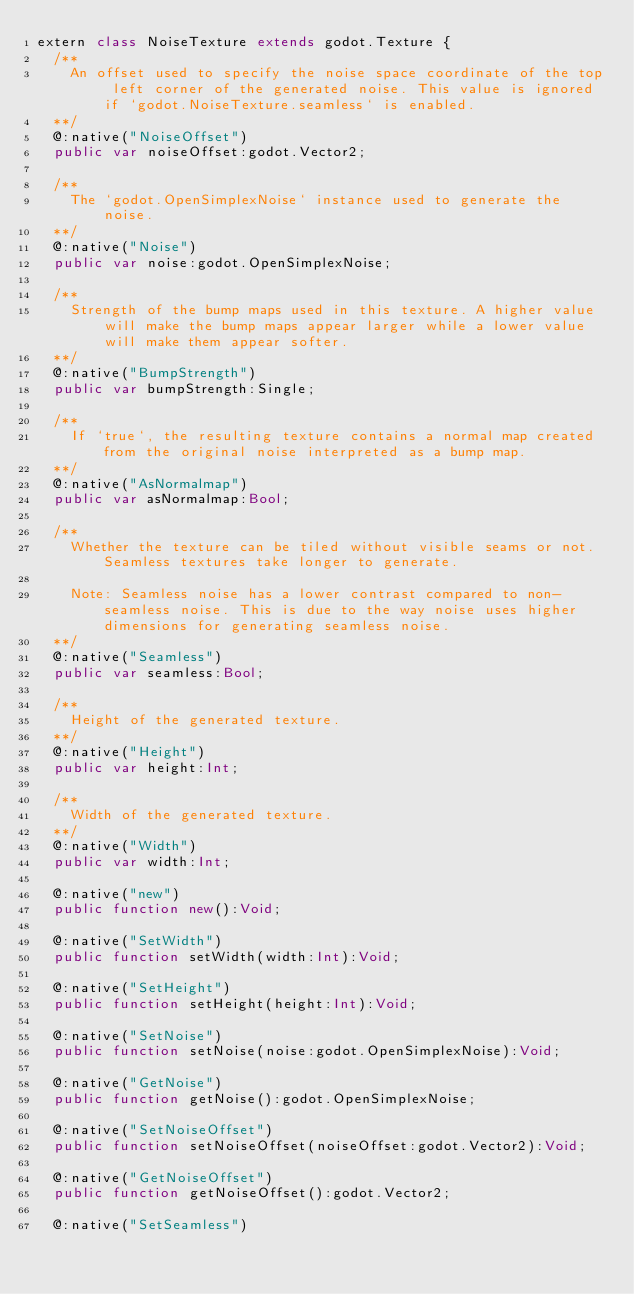<code> <loc_0><loc_0><loc_500><loc_500><_Haxe_>extern class NoiseTexture extends godot.Texture {
	/**		
		An offset used to specify the noise space coordinate of the top left corner of the generated noise. This value is ignored if `godot.NoiseTexture.seamless` is enabled.
	**/
	@:native("NoiseOffset")
	public var noiseOffset:godot.Vector2;

	/**		
		The `godot.OpenSimplexNoise` instance used to generate the noise.
	**/
	@:native("Noise")
	public var noise:godot.OpenSimplexNoise;

	/**		
		Strength of the bump maps used in this texture. A higher value will make the bump maps appear larger while a lower value will make them appear softer.
	**/
	@:native("BumpStrength")
	public var bumpStrength:Single;

	/**		
		If `true`, the resulting texture contains a normal map created from the original noise interpreted as a bump map.
	**/
	@:native("AsNormalmap")
	public var asNormalmap:Bool;

	/**		
		Whether the texture can be tiled without visible seams or not. Seamless textures take longer to generate.
		
		Note: Seamless noise has a lower contrast compared to non-seamless noise. This is due to the way noise uses higher dimensions for generating seamless noise.
	**/
	@:native("Seamless")
	public var seamless:Bool;

	/**		
		Height of the generated texture.
	**/
	@:native("Height")
	public var height:Int;

	/**		
		Width of the generated texture.
	**/
	@:native("Width")
	public var width:Int;

	@:native("new")
	public function new():Void;

	@:native("SetWidth")
	public function setWidth(width:Int):Void;

	@:native("SetHeight")
	public function setHeight(height:Int):Void;

	@:native("SetNoise")
	public function setNoise(noise:godot.OpenSimplexNoise):Void;

	@:native("GetNoise")
	public function getNoise():godot.OpenSimplexNoise;

	@:native("SetNoiseOffset")
	public function setNoiseOffset(noiseOffset:godot.Vector2):Void;

	@:native("GetNoiseOffset")
	public function getNoiseOffset():godot.Vector2;

	@:native("SetSeamless")</code> 